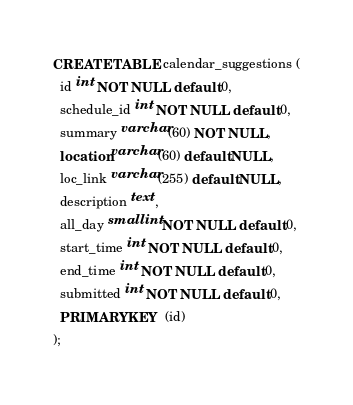Convert code to text. <code><loc_0><loc_0><loc_500><loc_500><_SQL_>CREATE TABLE calendar_suggestions (
  id int NOT NULL default 0,
  schedule_id int NOT NULL default 0,
  summary varchar(60) NOT NULL,
  location varchar(60) default NULL,
  loc_link varchar(255) default NULL,
  description text,
  all_day smallint NOT NULL default 0,
  start_time int NOT NULL default 0,
  end_time int NOT NULL default 0,
  submitted int NOT NULL default 0,
  PRIMARY KEY  (id)
);
</code> 